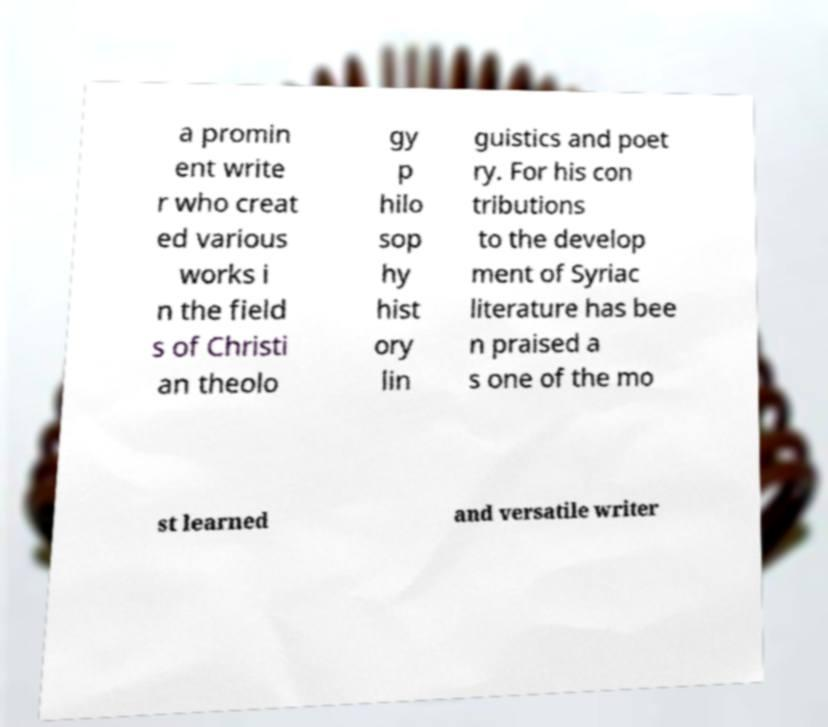Please identify and transcribe the text found in this image. a promin ent write r who creat ed various works i n the field s of Christi an theolo gy p hilo sop hy hist ory lin guistics and poet ry. For his con tributions to the develop ment of Syriac literature has bee n praised a s one of the mo st learned and versatile writer 